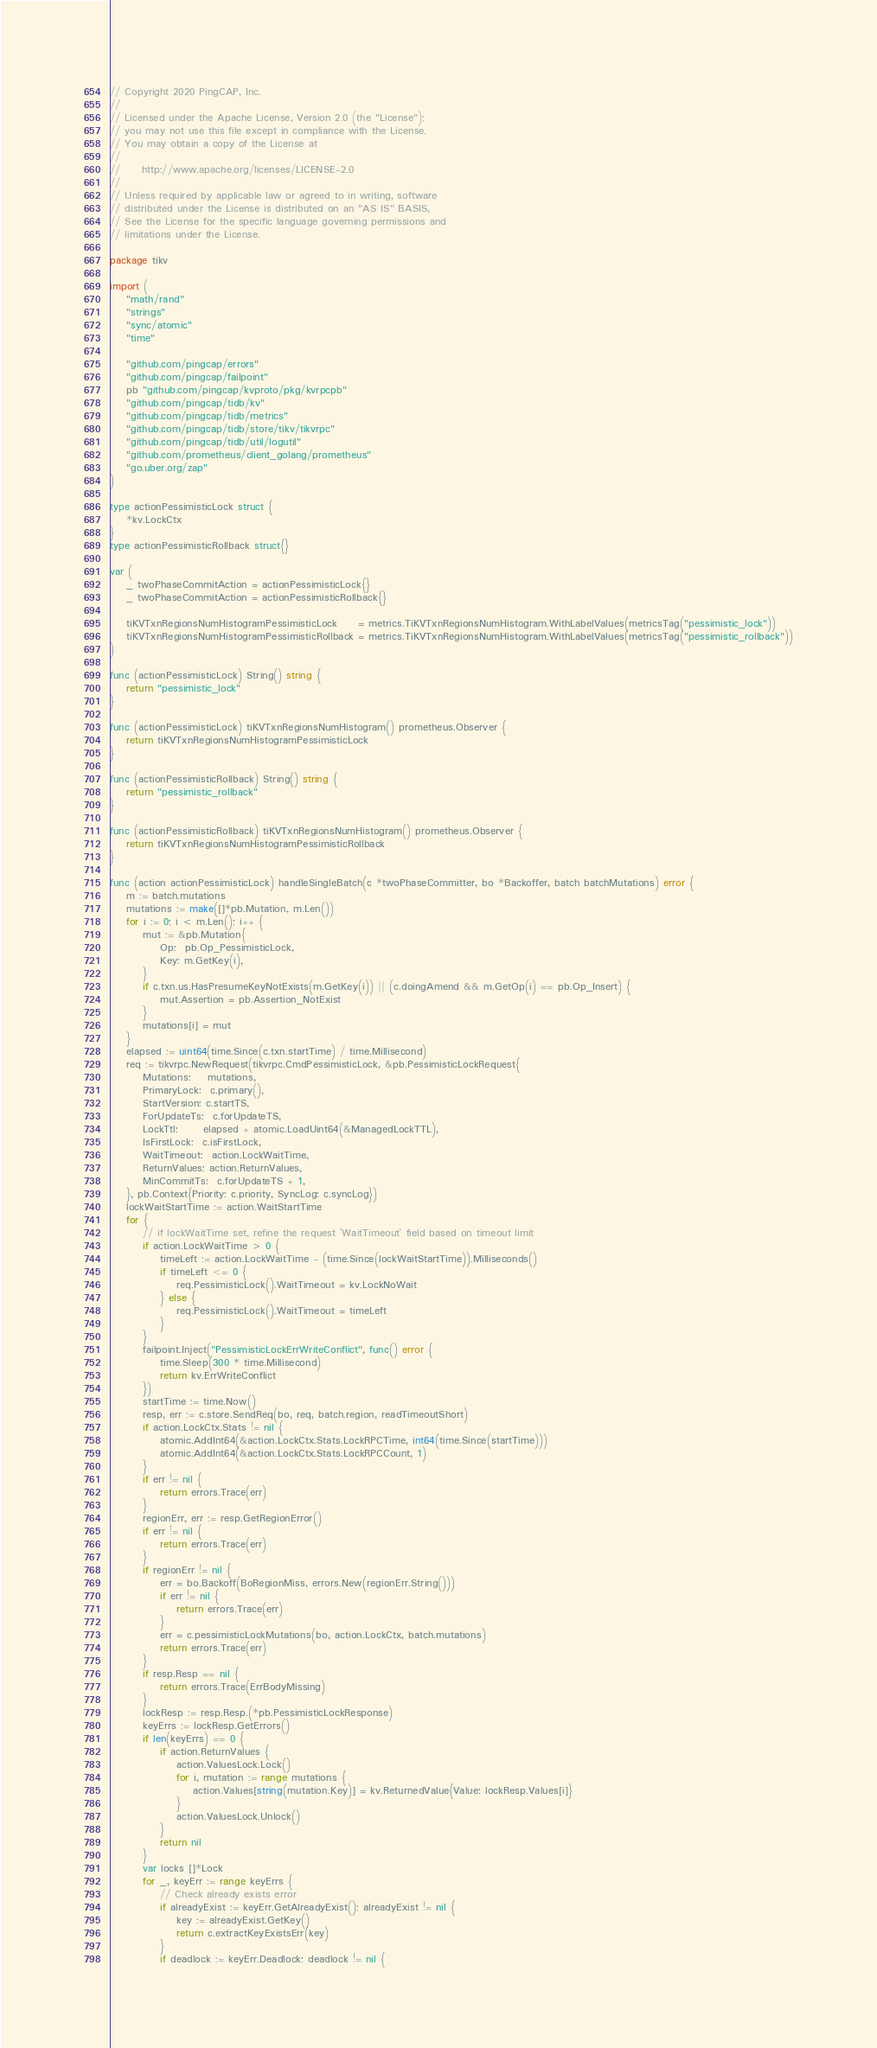Convert code to text. <code><loc_0><loc_0><loc_500><loc_500><_Go_>// Copyright 2020 PingCAP, Inc.
//
// Licensed under the Apache License, Version 2.0 (the "License");
// you may not use this file except in compliance with the License.
// You may obtain a copy of the License at
//
//     http://www.apache.org/licenses/LICENSE-2.0
//
// Unless required by applicable law or agreed to in writing, software
// distributed under the License is distributed on an "AS IS" BASIS,
// See the License for the specific language governing permissions and
// limitations under the License.

package tikv

import (
	"math/rand"
	"strings"
	"sync/atomic"
	"time"

	"github.com/pingcap/errors"
	"github.com/pingcap/failpoint"
	pb "github.com/pingcap/kvproto/pkg/kvrpcpb"
	"github.com/pingcap/tidb/kv"
	"github.com/pingcap/tidb/metrics"
	"github.com/pingcap/tidb/store/tikv/tikvrpc"
	"github.com/pingcap/tidb/util/logutil"
	"github.com/prometheus/client_golang/prometheus"
	"go.uber.org/zap"
)

type actionPessimisticLock struct {
	*kv.LockCtx
}
type actionPessimisticRollback struct{}

var (
	_ twoPhaseCommitAction = actionPessimisticLock{}
	_ twoPhaseCommitAction = actionPessimisticRollback{}

	tiKVTxnRegionsNumHistogramPessimisticLock     = metrics.TiKVTxnRegionsNumHistogram.WithLabelValues(metricsTag("pessimistic_lock"))
	tiKVTxnRegionsNumHistogramPessimisticRollback = metrics.TiKVTxnRegionsNumHistogram.WithLabelValues(metricsTag("pessimistic_rollback"))
)

func (actionPessimisticLock) String() string {
	return "pessimistic_lock"
}

func (actionPessimisticLock) tiKVTxnRegionsNumHistogram() prometheus.Observer {
	return tiKVTxnRegionsNumHistogramPessimisticLock
}

func (actionPessimisticRollback) String() string {
	return "pessimistic_rollback"
}

func (actionPessimisticRollback) tiKVTxnRegionsNumHistogram() prometheus.Observer {
	return tiKVTxnRegionsNumHistogramPessimisticRollback
}

func (action actionPessimisticLock) handleSingleBatch(c *twoPhaseCommitter, bo *Backoffer, batch batchMutations) error {
	m := batch.mutations
	mutations := make([]*pb.Mutation, m.Len())
	for i := 0; i < m.Len(); i++ {
		mut := &pb.Mutation{
			Op:  pb.Op_PessimisticLock,
			Key: m.GetKey(i),
		}
		if c.txn.us.HasPresumeKeyNotExists(m.GetKey(i)) || (c.doingAmend && m.GetOp(i) == pb.Op_Insert) {
			mut.Assertion = pb.Assertion_NotExist
		}
		mutations[i] = mut
	}
	elapsed := uint64(time.Since(c.txn.startTime) / time.Millisecond)
	req := tikvrpc.NewRequest(tikvrpc.CmdPessimisticLock, &pb.PessimisticLockRequest{
		Mutations:    mutations,
		PrimaryLock:  c.primary(),
		StartVersion: c.startTS,
		ForUpdateTs:  c.forUpdateTS,
		LockTtl:      elapsed + atomic.LoadUint64(&ManagedLockTTL),
		IsFirstLock:  c.isFirstLock,
		WaitTimeout:  action.LockWaitTime,
		ReturnValues: action.ReturnValues,
		MinCommitTs:  c.forUpdateTS + 1,
	}, pb.Context{Priority: c.priority, SyncLog: c.syncLog})
	lockWaitStartTime := action.WaitStartTime
	for {
		// if lockWaitTime set, refine the request `WaitTimeout` field based on timeout limit
		if action.LockWaitTime > 0 {
			timeLeft := action.LockWaitTime - (time.Since(lockWaitStartTime)).Milliseconds()
			if timeLeft <= 0 {
				req.PessimisticLock().WaitTimeout = kv.LockNoWait
			} else {
				req.PessimisticLock().WaitTimeout = timeLeft
			}
		}
		failpoint.Inject("PessimisticLockErrWriteConflict", func() error {
			time.Sleep(300 * time.Millisecond)
			return kv.ErrWriteConflict
		})
		startTime := time.Now()
		resp, err := c.store.SendReq(bo, req, batch.region, readTimeoutShort)
		if action.LockCtx.Stats != nil {
			atomic.AddInt64(&action.LockCtx.Stats.LockRPCTime, int64(time.Since(startTime)))
			atomic.AddInt64(&action.LockCtx.Stats.LockRPCCount, 1)
		}
		if err != nil {
			return errors.Trace(err)
		}
		regionErr, err := resp.GetRegionError()
		if err != nil {
			return errors.Trace(err)
		}
		if regionErr != nil {
			err = bo.Backoff(BoRegionMiss, errors.New(regionErr.String()))
			if err != nil {
				return errors.Trace(err)
			}
			err = c.pessimisticLockMutations(bo, action.LockCtx, batch.mutations)
			return errors.Trace(err)
		}
		if resp.Resp == nil {
			return errors.Trace(ErrBodyMissing)
		}
		lockResp := resp.Resp.(*pb.PessimisticLockResponse)
		keyErrs := lockResp.GetErrors()
		if len(keyErrs) == 0 {
			if action.ReturnValues {
				action.ValuesLock.Lock()
				for i, mutation := range mutations {
					action.Values[string(mutation.Key)] = kv.ReturnedValue{Value: lockResp.Values[i]}
				}
				action.ValuesLock.Unlock()
			}
			return nil
		}
		var locks []*Lock
		for _, keyErr := range keyErrs {
			// Check already exists error
			if alreadyExist := keyErr.GetAlreadyExist(); alreadyExist != nil {
				key := alreadyExist.GetKey()
				return c.extractKeyExistsErr(key)
			}
			if deadlock := keyErr.Deadlock; deadlock != nil {</code> 